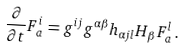Convert formula to latex. <formula><loc_0><loc_0><loc_500><loc_500>\frac { \partial } { \partial t } F _ { a } ^ { i } = g ^ { i j } g ^ { \alpha \beta } h _ { \alpha j l } H _ { \beta } F _ { a } ^ { l } \, .</formula> 